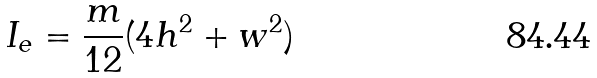Convert formula to latex. <formula><loc_0><loc_0><loc_500><loc_500>I _ { e } = \frac { m } { 1 2 } ( 4 h ^ { 2 } + w ^ { 2 } )</formula> 